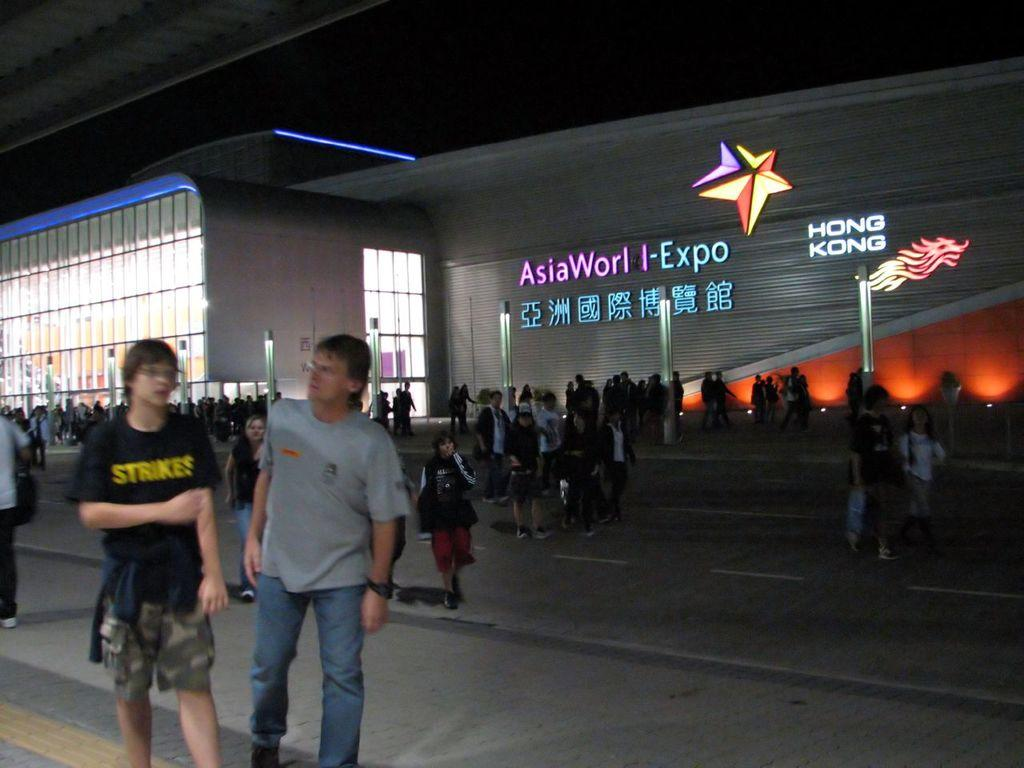What type of structure is visible in the image? There is a building in the image. What can be seen on the building? The building has text and logos on it. What objects are in front of the building? There are poles in front of the building. Who or what is in front of the building? There is a group of people in front of the building. Reasoning: Let's think step by step by step in order to produce the conversation. We start by identifying the main subject in the image, which is the building. Then, we expand the conversation to include other details about the building, such as the text and logos on it. Next, we mention the objects in front of the building, which are the poles. Finally, we describe the people or other subjects in front of the building, which in this case is a group of people. Absurd Question/Answer: What type of holiday is being celebrated by the van and coach in the image? There is no van or coach present in the image, so it is not possible to determine if a holiday is being celebrated. 